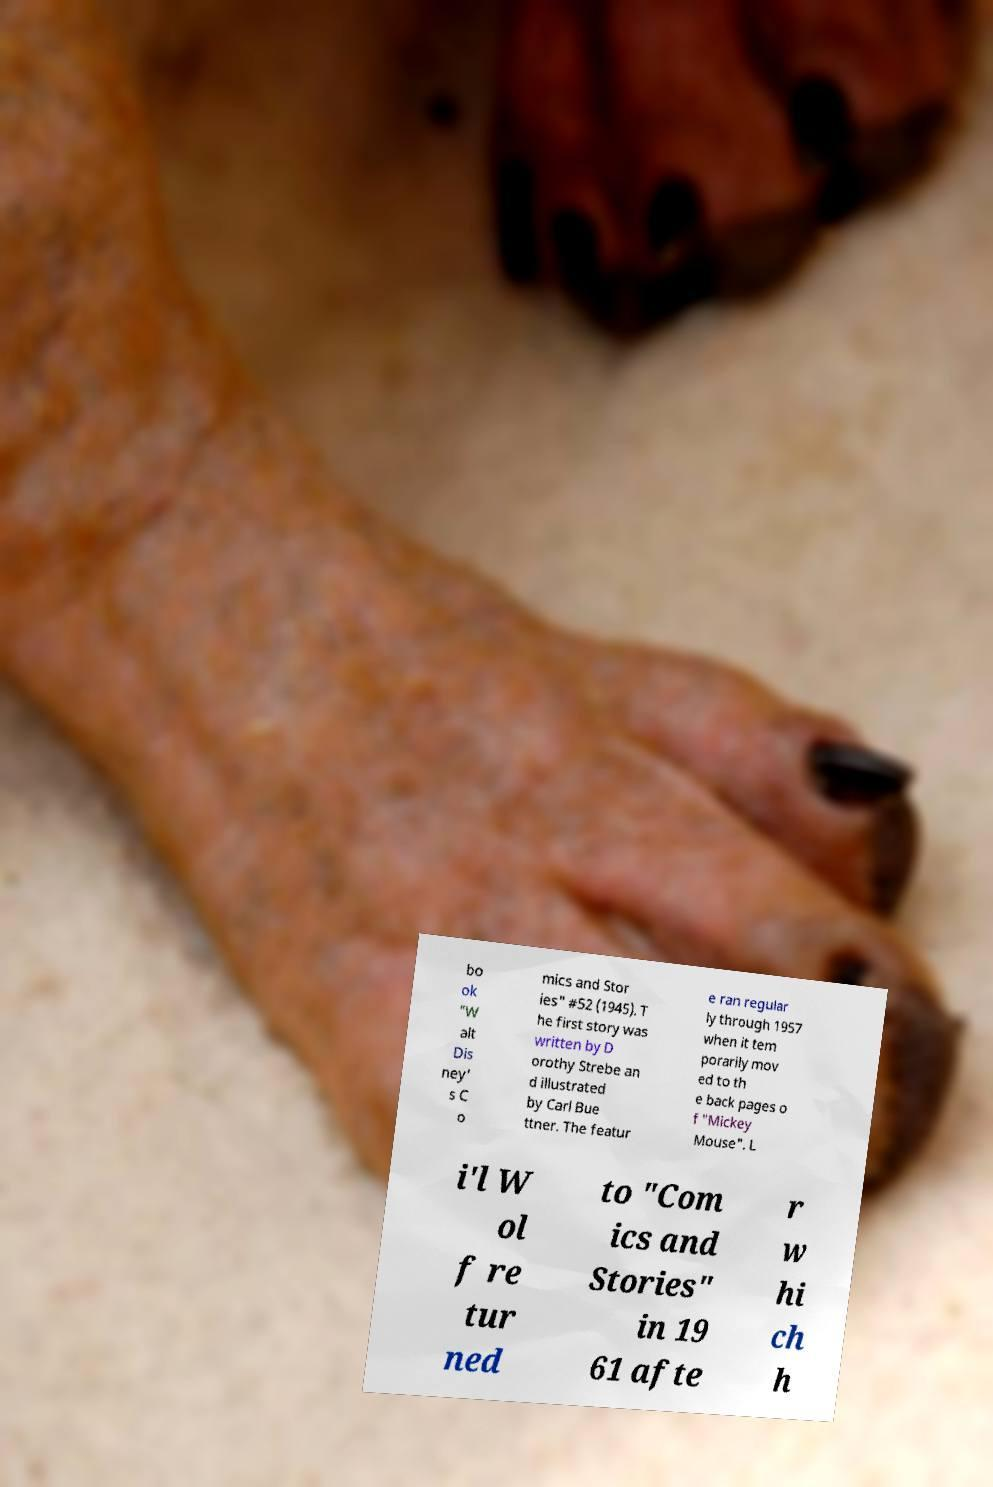Can you accurately transcribe the text from the provided image for me? bo ok "W alt Dis ney' s C o mics and Stor ies" #52 (1945). T he first story was written by D orothy Strebe an d illustrated by Carl Bue ttner. The featur e ran regular ly through 1957 when it tem porarily mov ed to th e back pages o f "Mickey Mouse". L i'l W ol f re tur ned to "Com ics and Stories" in 19 61 afte r w hi ch h 